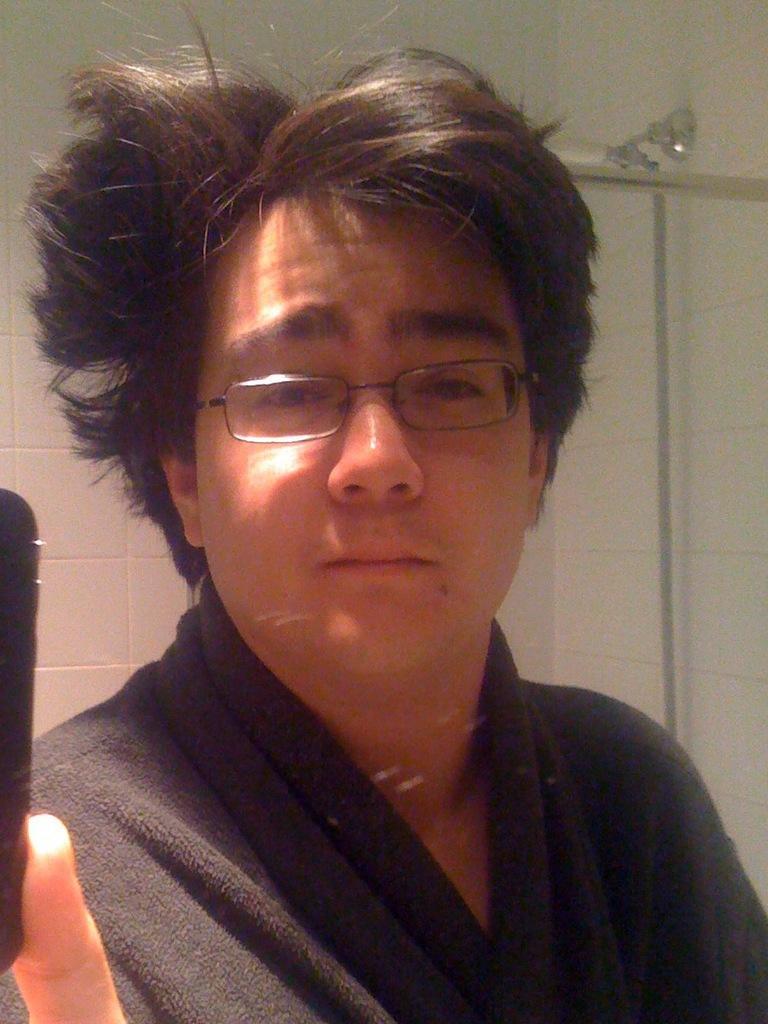In one or two sentences, can you explain what this image depicts? In the image I can a guy wearing black dress and spectacles. 